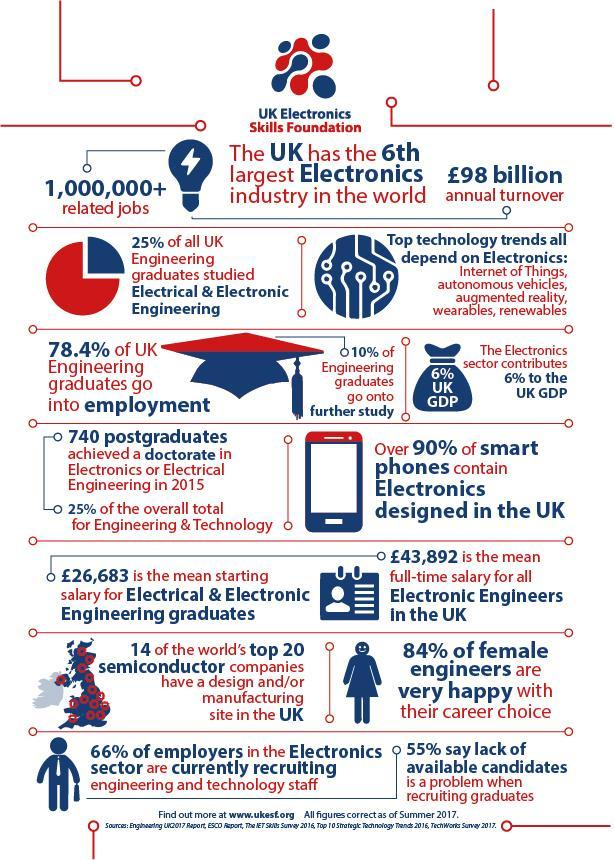What percentage of employers suggest their is a shortage of educated workforce in the electronics field, 66%, 84%, or 55%?
Answer the question with a short phrase. 55% What percentage of electronics engineers in the UK pursue higher education? 10% 